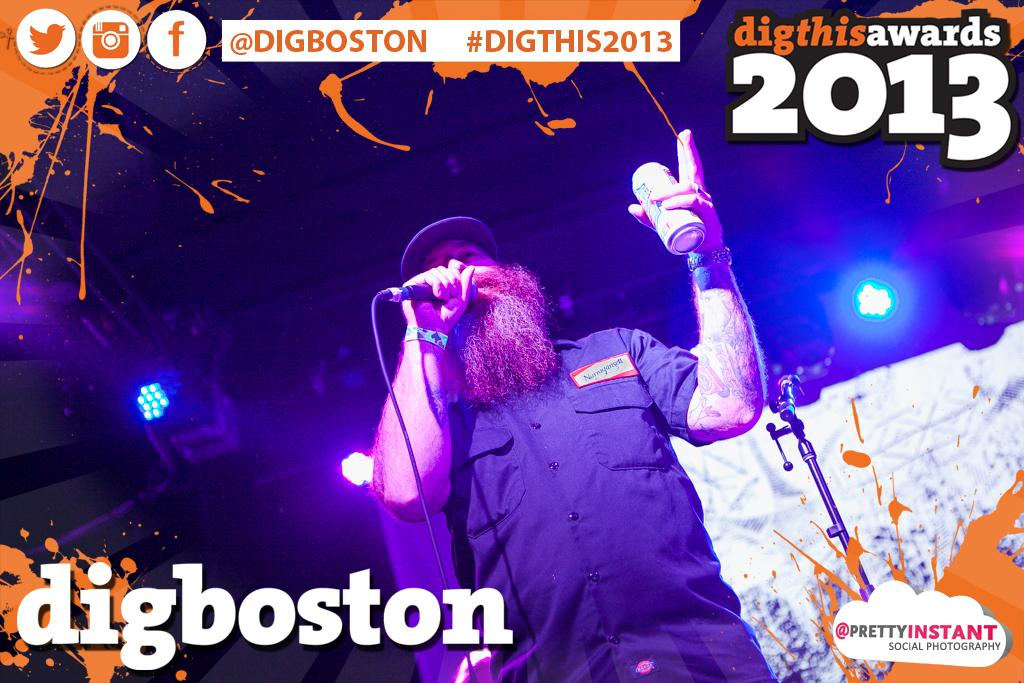Provide a one-sentence caption for the provided image. A photograph of a man with a microphone is labelled digboston and dated 2013. 